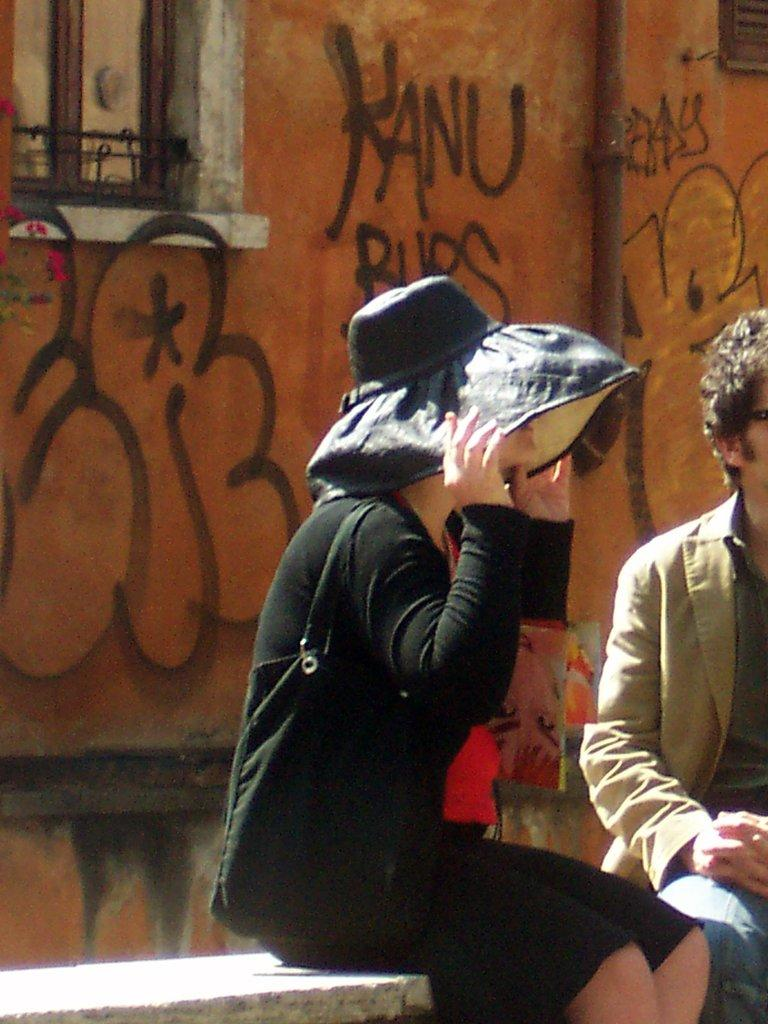<image>
Provide a brief description of the given image. A woman holds on to her hat above a graffiti sign that says KANU 